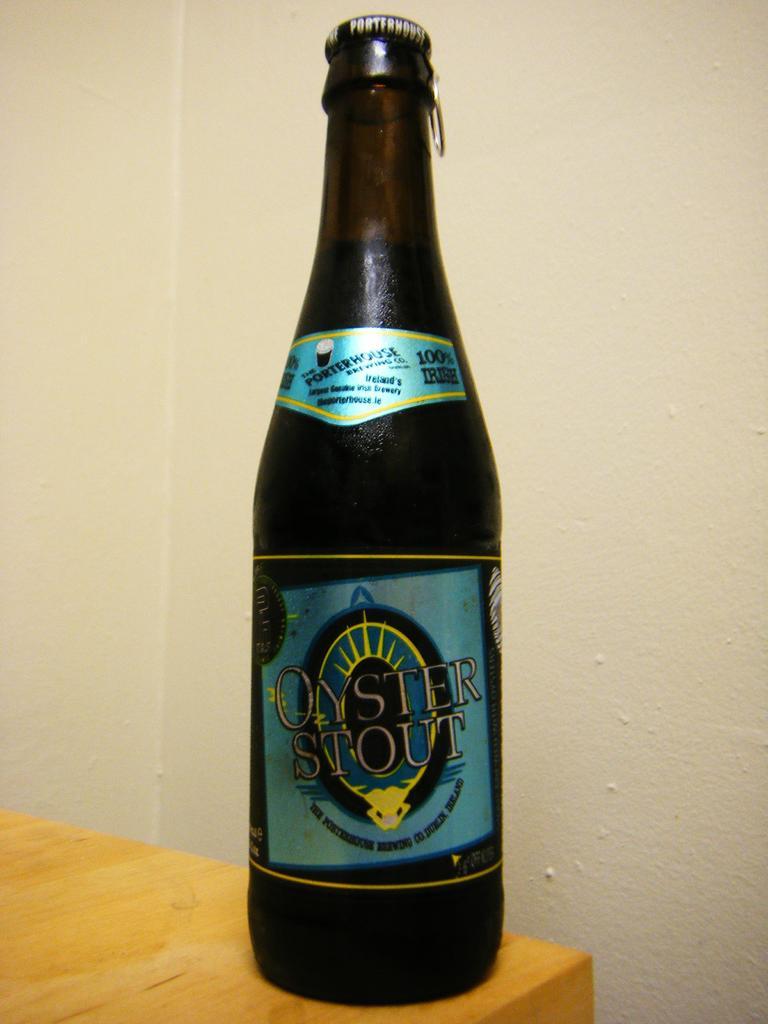What kind of stout is this beverage?
Your response must be concise. Oyster. How much irish?
Your answer should be compact. 100%. 